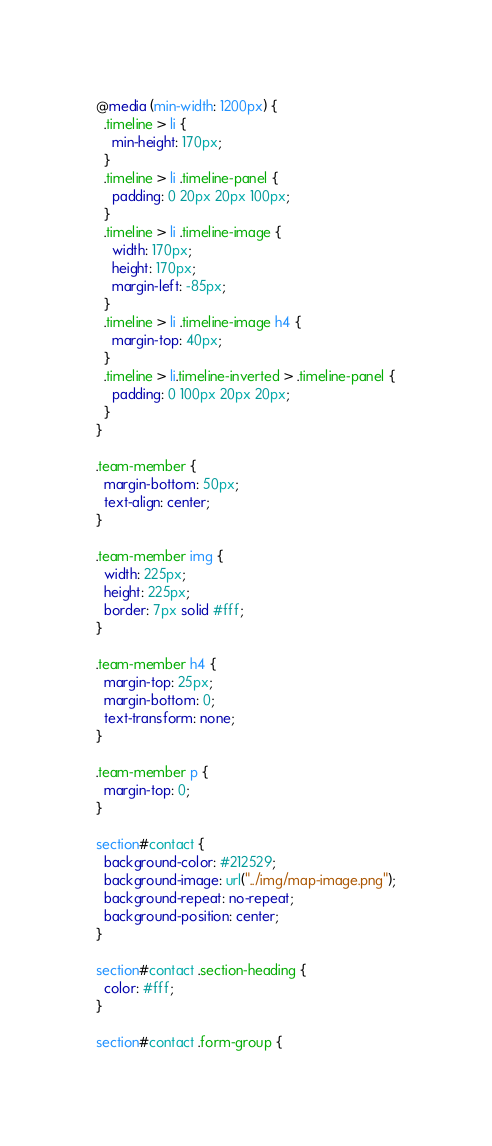Convert code to text. <code><loc_0><loc_0><loc_500><loc_500><_CSS_>@media (min-width: 1200px) {
  .timeline > li {
    min-height: 170px;
  }
  .timeline > li .timeline-panel {
    padding: 0 20px 20px 100px;
  }
  .timeline > li .timeline-image {
    width: 170px;
    height: 170px;
    margin-left: -85px;
  }
  .timeline > li .timeline-image h4 {
    margin-top: 40px;
  }
  .timeline > li.timeline-inverted > .timeline-panel {
    padding: 0 100px 20px 20px;
  }
}

.team-member {
  margin-bottom: 50px;
  text-align: center;
}

.team-member img {
  width: 225px;
  height: 225px;
  border: 7px solid #fff;
}

.team-member h4 {
  margin-top: 25px;
  margin-bottom: 0;
  text-transform: none;
}

.team-member p {
  margin-top: 0;
}

section#contact {
  background-color: #212529;
  background-image: url("../img/map-image.png");
  background-repeat: no-repeat;
  background-position: center;
}

section#contact .section-heading {
  color: #fff;
}

section#contact .form-group {</code> 